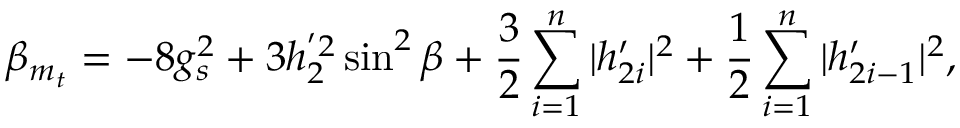<formula> <loc_0><loc_0><loc_500><loc_500>\beta _ { m _ { t } } = - 8 g _ { s } ^ { 2 } + 3 h _ { 2 } ^ { ^ { \prime } 2 } \sin ^ { 2 } \beta + \frac { 3 } { 2 } \sum _ { i = 1 } ^ { n } | h _ { 2 i } ^ { \prime } | ^ { 2 } + \frac { 1 } { 2 } \sum _ { i = 1 } ^ { n } | h _ { 2 i - 1 } ^ { \prime } | ^ { 2 } ,</formula> 